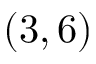Convert formula to latex. <formula><loc_0><loc_0><loc_500><loc_500>( 3 , 6 )</formula> 